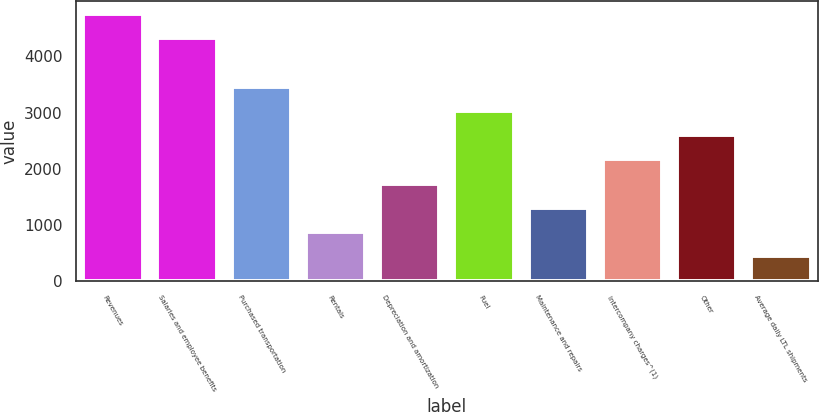Convert chart. <chart><loc_0><loc_0><loc_500><loc_500><bar_chart><fcel>Revenues<fcel>Salaries and employee benefits<fcel>Purchased transportation<fcel>Rentals<fcel>Depreciation and amortization<fcel>Fuel<fcel>Maintenance and repairs<fcel>Intercompany charges^(1)<fcel>Other<fcel>Average daily LTL shipments<nl><fcel>4751.36<fcel>4320.97<fcel>3460.19<fcel>877.85<fcel>1738.63<fcel>3029.8<fcel>1308.24<fcel>2169.02<fcel>2599.41<fcel>447.46<nl></chart> 